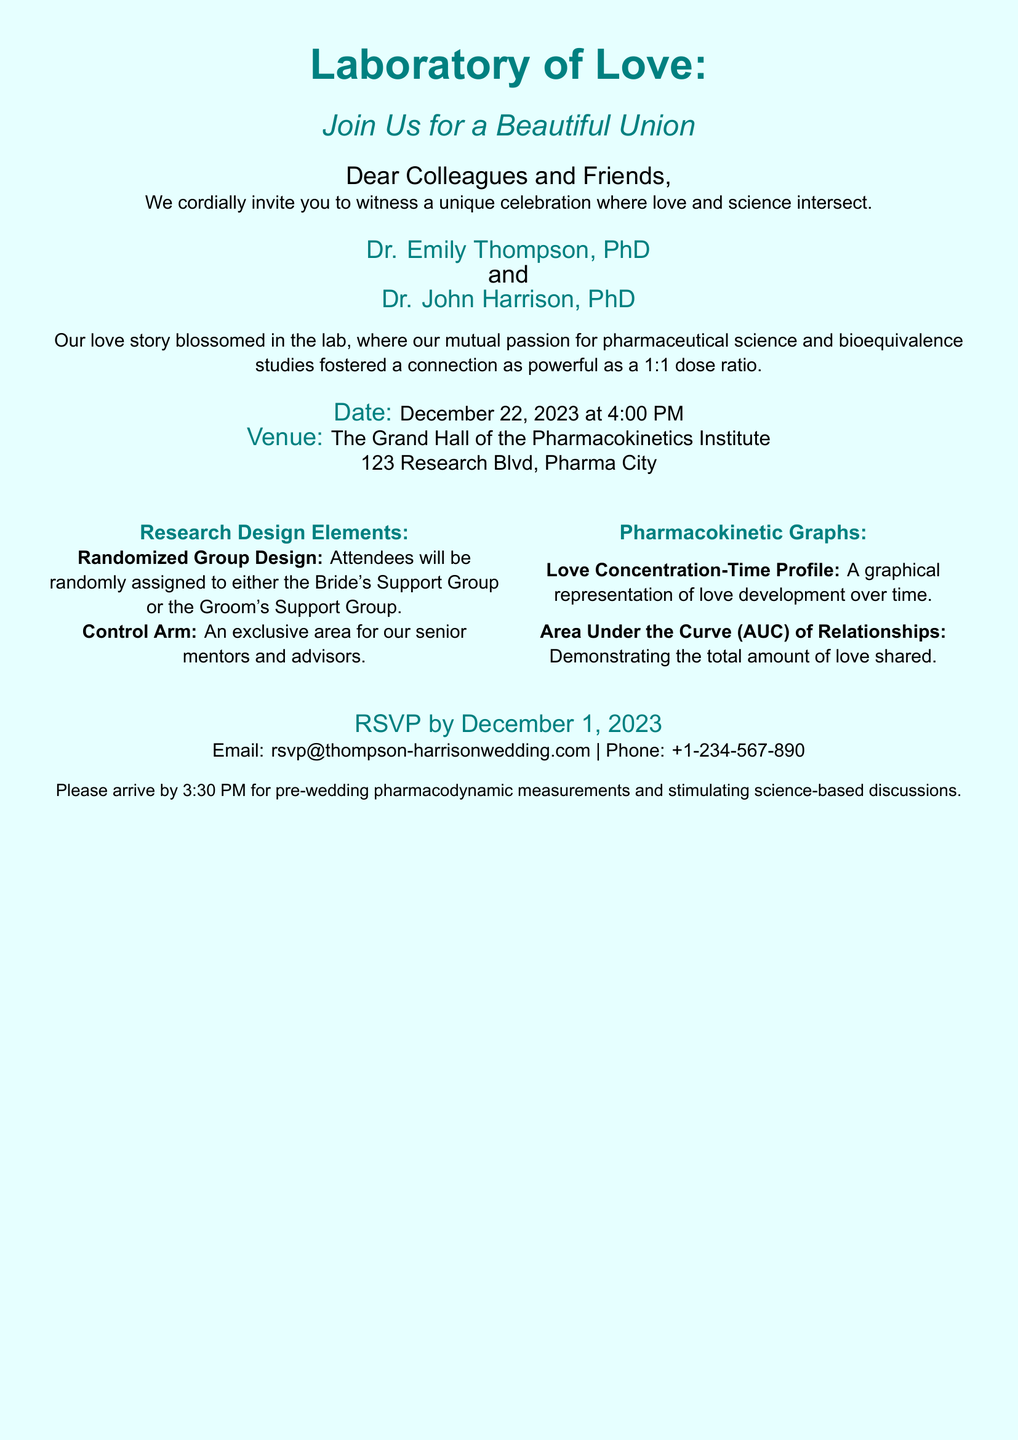What is the names of the couple? The names of the couple are mentioned in the document as Dr. Emily Thompson and Dr. John Harrison.
Answer: Dr. Emily Thompson, Dr. John Harrison What is the date of the wedding? The date of the wedding is explicitly stated in the document as December 22, 2023.
Answer: December 22, 2023 What time does the wedding start? The document specifies that the wedding starts at 4:00 PM.
Answer: 4:00 PM Where is the wedding venue? The venue for the wedding is detailed in the document as The Grand Hall of the Pharmacokinetics Institute.
Answer: The Grand Hall of the Pharmacokinetics Institute What should attendees arrive for by 3:30 PM? The document mentions that attendees should arrive by 3:30 PM for pre-wedding pharmacodynamic measurements and discussions.
Answer: Pre-wedding pharmacodynamic measurements What will attendees be randomly assigned to? The document states that attendees will be randomly assigned to either the Bride's Support Group or the Groom's Support Group.
Answer: Bride's Support Group or Groom's Support Group What is the RSVP deadline? The RSVP deadline is provided in the document as December 1, 2023.
Answer: December 1, 2023 What is represented by the "Area Under the Curve" in the invitation? This term relates to the total amount of love shared between the couple, as noted in the document under pharmacokinetic graphs.
Answer: Total amount of love shared What type of celebration is described in the invitation? The document describes the celebration as a unique celebration where love and science intersect.
Answer: Unique celebration where love and science intersect What is the main theme of the invitation? The invitation's theme combines elements of love and scientific research, particularly in pharmaceutical science.
Answer: Love and science 